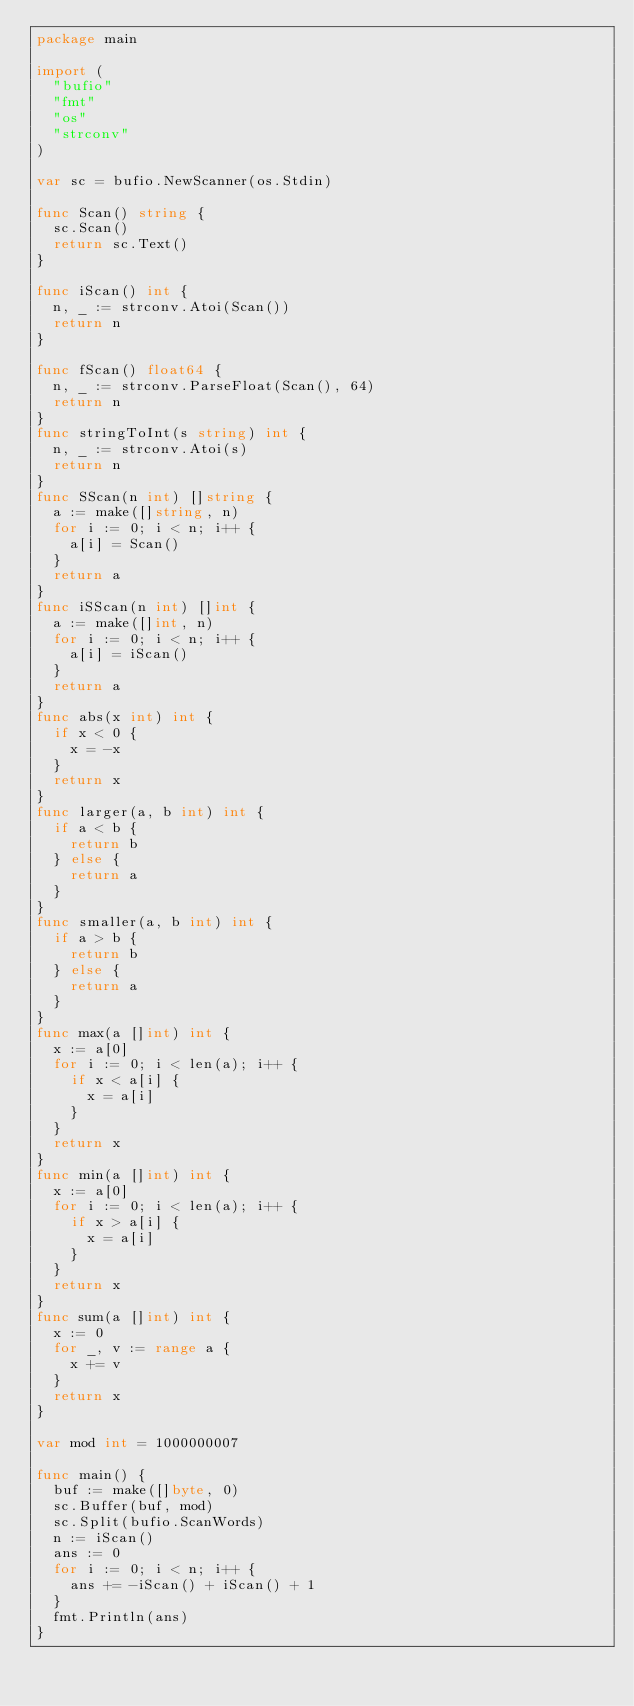<code> <loc_0><loc_0><loc_500><loc_500><_Go_>package main

import (
	"bufio"
	"fmt"
	"os"
	"strconv"
)

var sc = bufio.NewScanner(os.Stdin)

func Scan() string {
	sc.Scan()
	return sc.Text()
}

func iScan() int {
	n, _ := strconv.Atoi(Scan())
	return n
}

func fScan() float64 {
	n, _ := strconv.ParseFloat(Scan(), 64)
	return n
}
func stringToInt(s string) int {
	n, _ := strconv.Atoi(s)
	return n
}
func SScan(n int) []string {
	a := make([]string, n)
	for i := 0; i < n; i++ {
		a[i] = Scan()
	}
	return a
}
func iSScan(n int) []int {
	a := make([]int, n)
	for i := 0; i < n; i++ {
		a[i] = iScan()
	}
	return a
}
func abs(x int) int {
	if x < 0 {
		x = -x
	}
	return x
}
func larger(a, b int) int {
	if a < b {
		return b
	} else {
		return a
	}
}
func smaller(a, b int) int {
	if a > b {
		return b
	} else {
		return a
	}
}
func max(a []int) int {
	x := a[0]
	for i := 0; i < len(a); i++ {
		if x < a[i] {
			x = a[i]
		}
	}
	return x
}
func min(a []int) int {
	x := a[0]
	for i := 0; i < len(a); i++ {
		if x > a[i] {
			x = a[i]
		}
	}
	return x
}
func sum(a []int) int {
	x := 0
	for _, v := range a {
		x += v
	}
	return x
}

var mod int = 1000000007

func main() {
	buf := make([]byte, 0)
	sc.Buffer(buf, mod)
	sc.Split(bufio.ScanWords)
	n := iScan()
	ans := 0
	for i := 0; i < n; i++ {
		ans += -iScan() + iScan() + 1
	}
	fmt.Println(ans)
}
</code> 